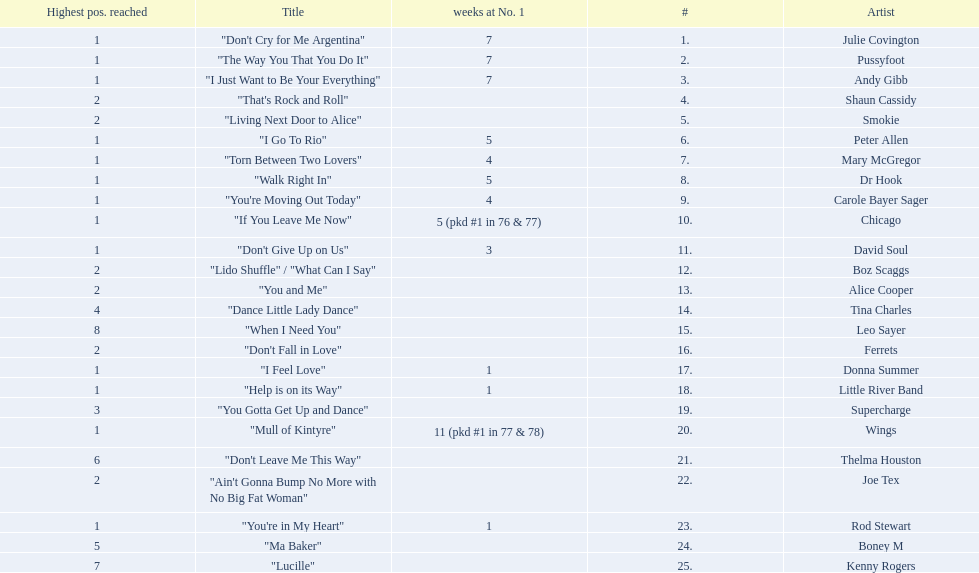Who had the one of the least weeks at number one? Rod Stewart. Who had no week at number one? Shaun Cassidy. Who had the highest number of weeks at number one? Wings. 